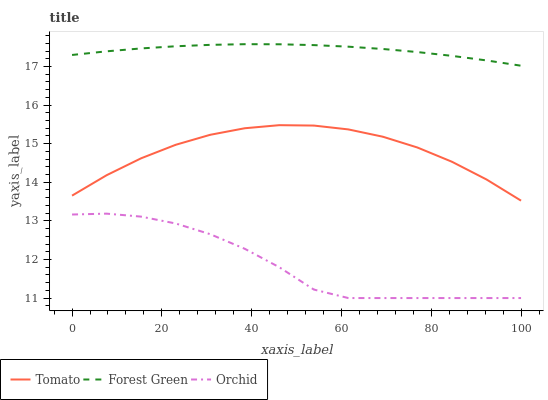Does Orchid have the minimum area under the curve?
Answer yes or no. Yes. Does Forest Green have the maximum area under the curve?
Answer yes or no. Yes. Does Forest Green have the minimum area under the curve?
Answer yes or no. No. Does Orchid have the maximum area under the curve?
Answer yes or no. No. Is Forest Green the smoothest?
Answer yes or no. Yes. Is Orchid the roughest?
Answer yes or no. Yes. Is Orchid the smoothest?
Answer yes or no. No. Is Forest Green the roughest?
Answer yes or no. No. Does Orchid have the lowest value?
Answer yes or no. Yes. Does Forest Green have the lowest value?
Answer yes or no. No. Does Forest Green have the highest value?
Answer yes or no. Yes. Does Orchid have the highest value?
Answer yes or no. No. Is Tomato less than Forest Green?
Answer yes or no. Yes. Is Forest Green greater than Tomato?
Answer yes or no. Yes. Does Tomato intersect Forest Green?
Answer yes or no. No. 